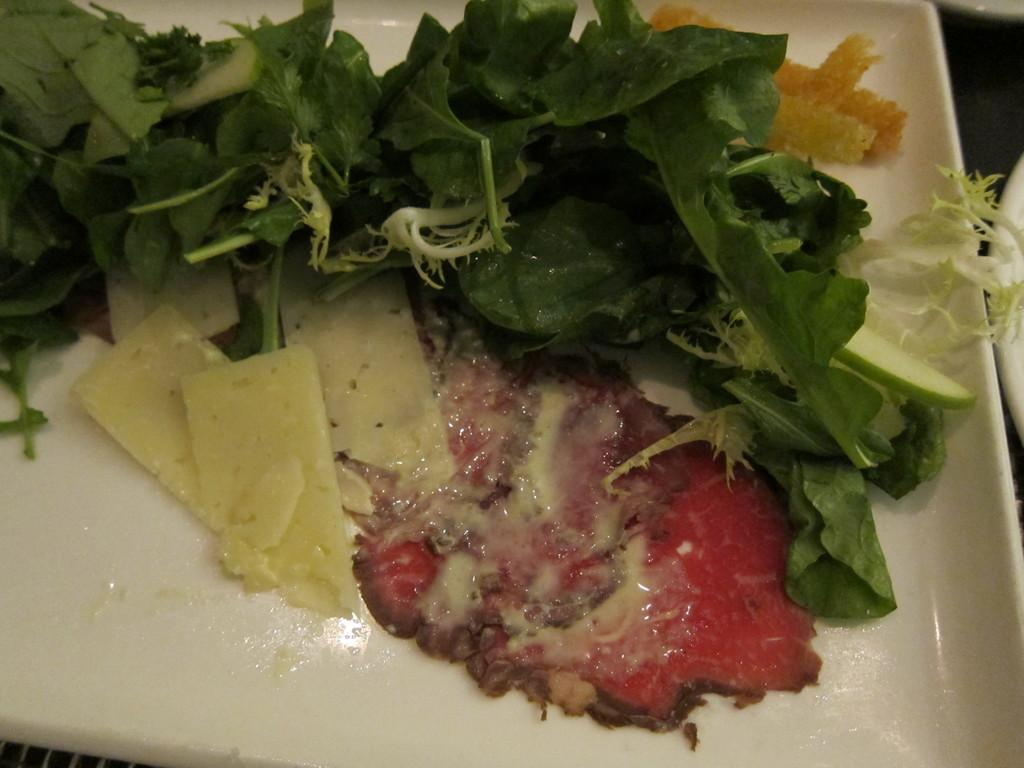What object can be seen in the image that is typically used for serving food? There is a plate in the image. What is on the plate in the image? There is food on the plate. How many turkeys are visible in the image? There are no turkeys present in the image. What shape is the plate in the image? The shape of the plate is not mentioned in the provided facts, so it cannot be determined from the image. 